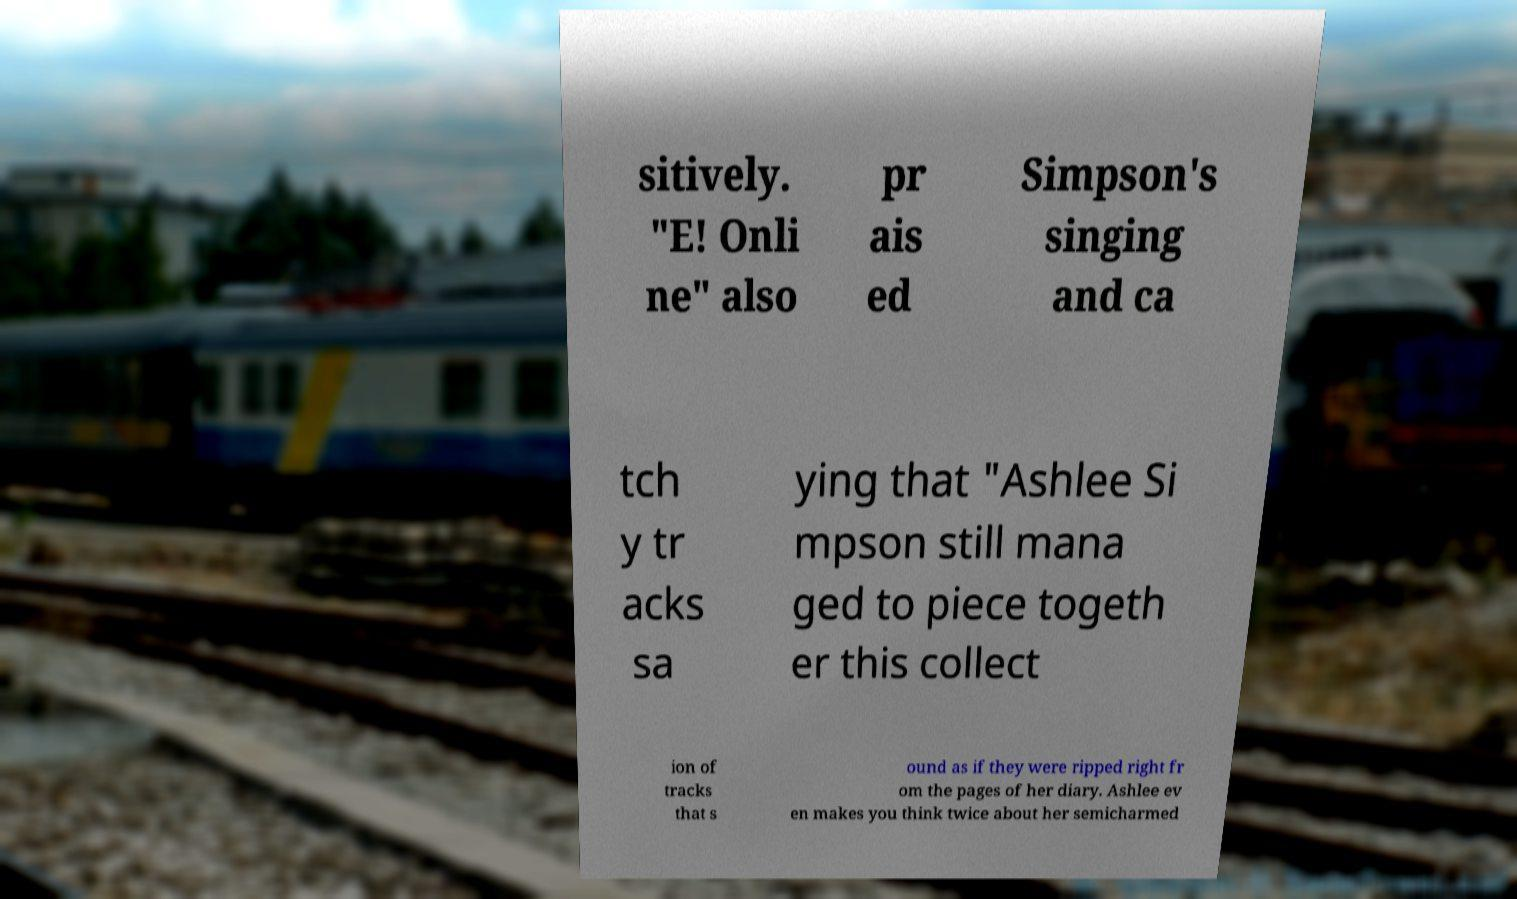For documentation purposes, I need the text within this image transcribed. Could you provide that? sitively. "E! Onli ne" also pr ais ed Simpson's singing and ca tch y tr acks sa ying that "Ashlee Si mpson still mana ged to piece togeth er this collect ion of tracks that s ound as if they were ripped right fr om the pages of her diary. Ashlee ev en makes you think twice about her semicharmed 